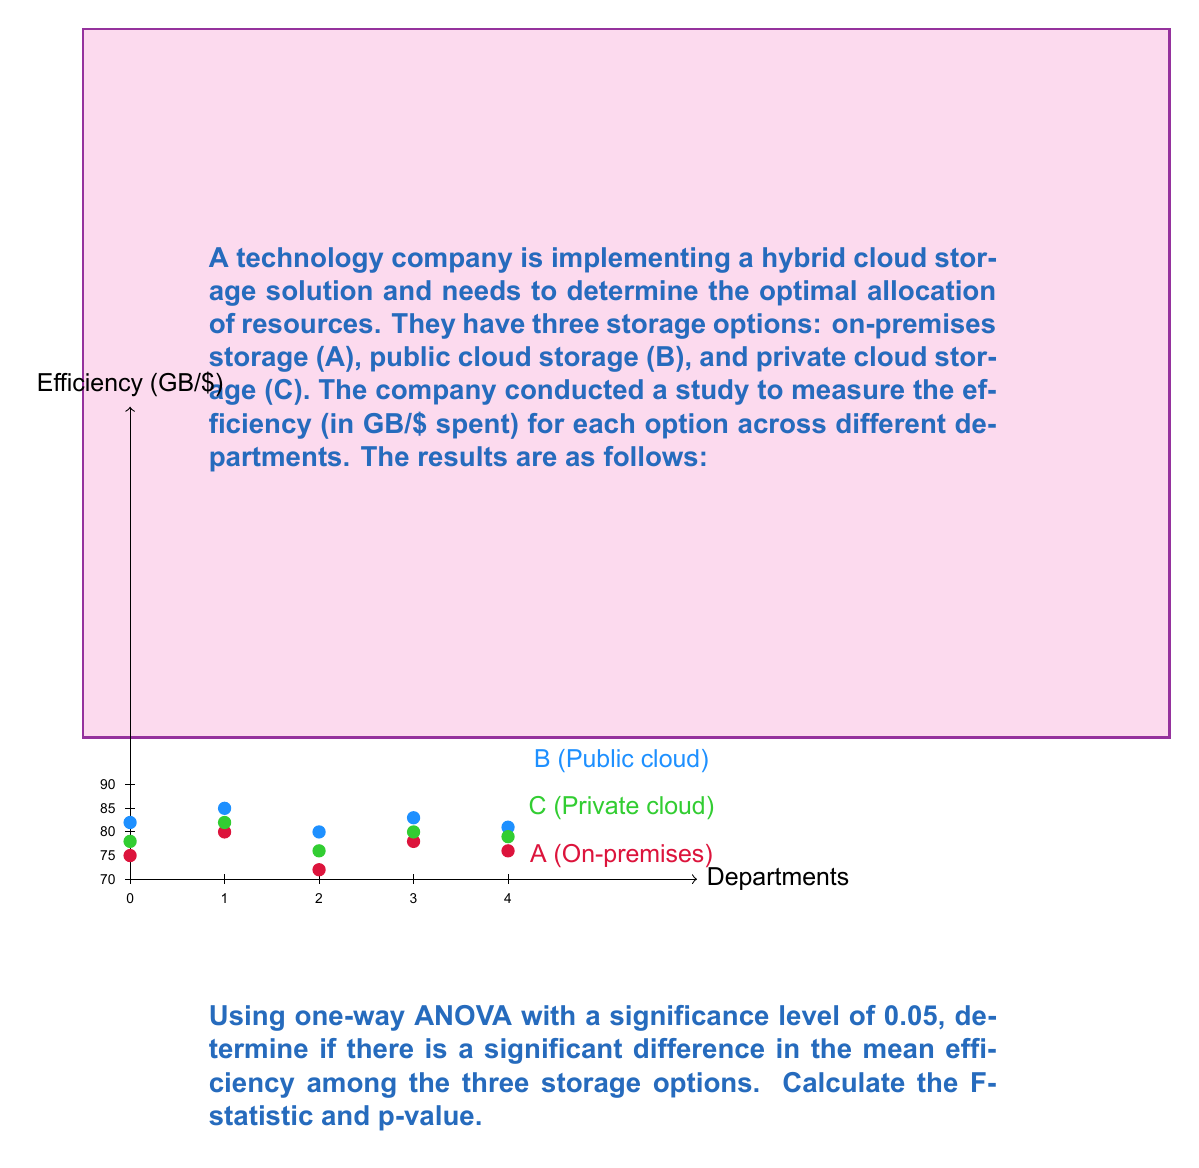Can you answer this question? To solve this problem, we'll follow these steps:

1. Calculate the sum of squares between groups (SSB) and within groups (SSW)
2. Calculate the degrees of freedom
3. Compute the mean square between groups (MSB) and within groups (MSW)
4. Calculate the F-statistic
5. Determine the p-value

Step 1: Calculate SSB and SSW

First, we need to calculate the grand mean:
$$\bar{X} = \frac{(75+80+72+78+76) + (82+85+80+83+81) + (78+82+76+80+79)}{15} = 79.13$$

Now, we calculate SSB:
$$SSB = 5[(76.2-79.13)^2 + (82.2-79.13)^2 + (79-79.13)^2] = 90.13$$

For SSW, we calculate the sum of squared deviations within each group:
$$SSW_A = (75-76.2)^2 + (80-76.2)^2 + (72-76.2)^2 + (78-76.2)^2 + (76-76.2)^2 = 36.8$$
$$SSW_B = (82-82.2)^2 + (85-82.2)^2 + (80-82.2)^2 + (83-82.2)^2 + (81-82.2)^2 = 14.8$$
$$SSW_C = (78-79)^2 + (82-79)^2 + (76-79)^2 + (80-79)^2 + (79-79)^2 = 18$$

$$SSW = SSW_A + SSW_B + SSW_C = 36.8 + 14.8 + 18 = 69.6$$

Step 2: Calculate degrees of freedom

$$df_{between} = k - 1 = 3 - 1 = 2$$
$$df_{within} = N - k = 15 - 3 = 12$$

Where k is the number of groups and N is the total number of observations.

Step 3: Compute MSB and MSW

$$MSB = \frac{SSB}{df_{between}} = \frac{90.13}{2} = 45.065$$
$$MSW = \frac{SSW}{df_{within}} = \frac{69.6}{12} = 5.8$$

Step 4: Calculate the F-statistic

$$F = \frac{MSB}{MSW} = \frac{45.065}{5.8} = 7.77$$

Step 5: Determine the p-value

Using an F-distribution calculator with df1 = 2 and df2 = 12, we find:

p-value ≈ 0.007

Since the p-value (0.007) is less than the significance level (0.05), we reject the null hypothesis. This means there is a significant difference in the mean efficiency among the three storage options.
Answer: F-statistic = 7.77, p-value ≈ 0.007 